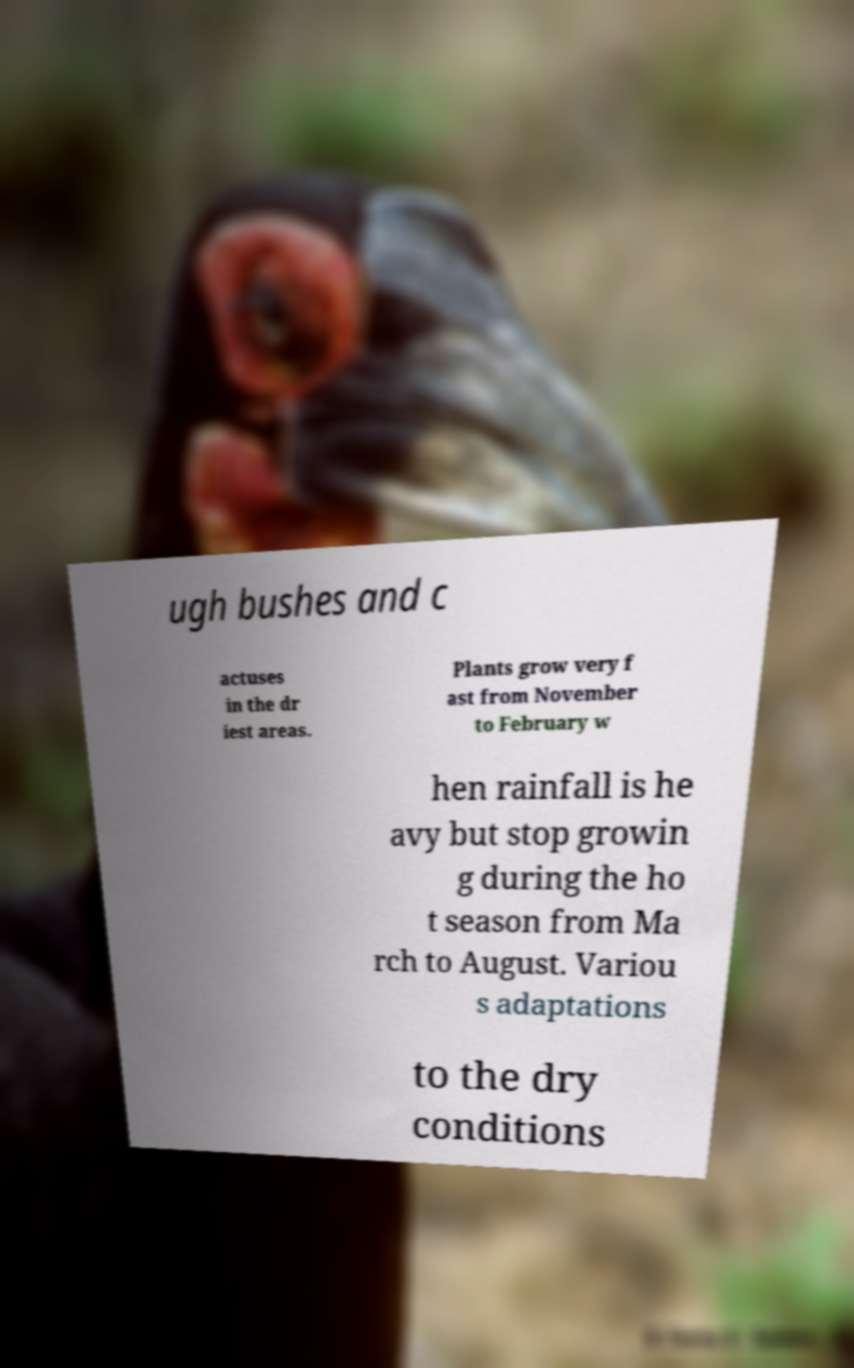There's text embedded in this image that I need extracted. Can you transcribe it verbatim? ugh bushes and c actuses in the dr iest areas. Plants grow very f ast from November to February w hen rainfall is he avy but stop growin g during the ho t season from Ma rch to August. Variou s adaptations to the dry conditions 